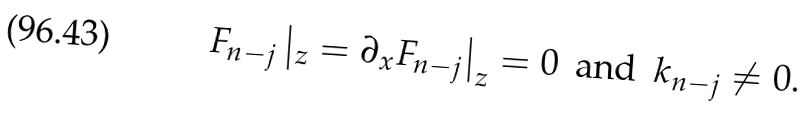<formula> <loc_0><loc_0><loc_500><loc_500>F _ { n - j } \left | _ { z } = \partial _ { x } F _ { n - j } \right | _ { z } = 0 \, \text { and } \, k _ { n - j } \not = 0 .</formula> 